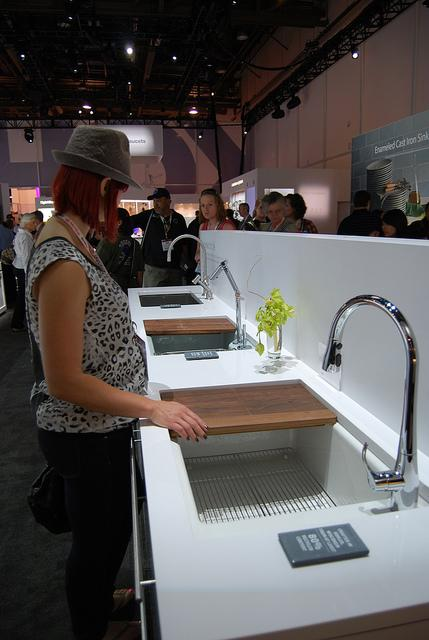If this person wanted to wash their hands where would they have to go? sink 